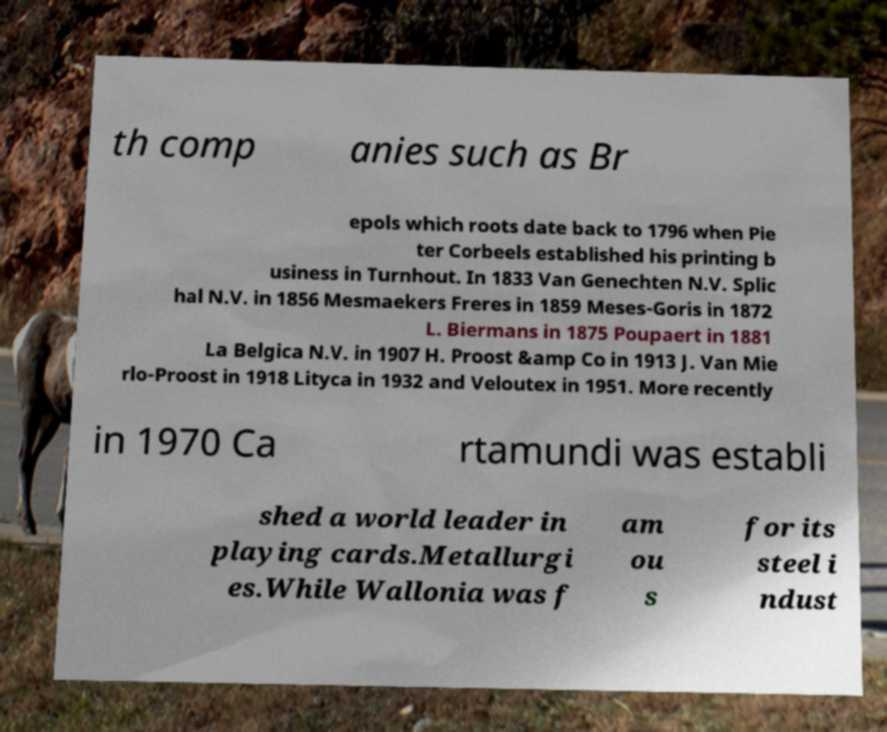Can you read and provide the text displayed in the image?This photo seems to have some interesting text. Can you extract and type it out for me? th comp anies such as Br epols which roots date back to 1796 when Pie ter Corbeels established his printing b usiness in Turnhout. In 1833 Van Genechten N.V. Splic hal N.V. in 1856 Mesmaekers Freres in 1859 Meses-Goris in 1872 L. Biermans in 1875 Poupaert in 1881 La Belgica N.V. in 1907 H. Proost &amp Co in 1913 J. Van Mie rlo-Proost in 1918 Lityca in 1932 and Veloutex in 1951. More recently in 1970 Ca rtamundi was establi shed a world leader in playing cards.Metallurgi es.While Wallonia was f am ou s for its steel i ndust 